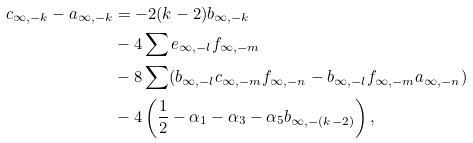<formula> <loc_0><loc_0><loc_500><loc_500>c _ { \infty , - k } - a _ { \infty , - k } & = - 2 ( k - 2 ) b _ { \infty , - k } \\ & - 4 \sum e _ { \infty , - l } f _ { \infty , - m } \\ & - 8 \sum ( b _ { \infty , - l } c _ { \infty , - m } f _ { \infty , - n } - b _ { \infty , - l } f _ { \infty , - m } a _ { \infty , - n } ) \\ & - 4 \left ( \frac { 1 } { 2 } - \alpha _ { 1 } - \alpha _ { 3 } - \alpha _ { 5 } b _ { \infty , - ( k - 2 ) } \right ) ,</formula> 